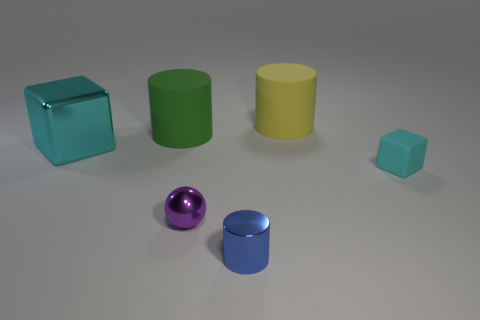Add 2 small red balls. How many objects exist? 8 Subtract all blocks. How many objects are left? 4 Subtract 0 brown cylinders. How many objects are left? 6 Subtract all tiny cyan metal cylinders. Subtract all small matte things. How many objects are left? 5 Add 1 purple metal spheres. How many purple metal spheres are left? 2 Add 5 small purple matte cylinders. How many small purple matte cylinders exist? 5 